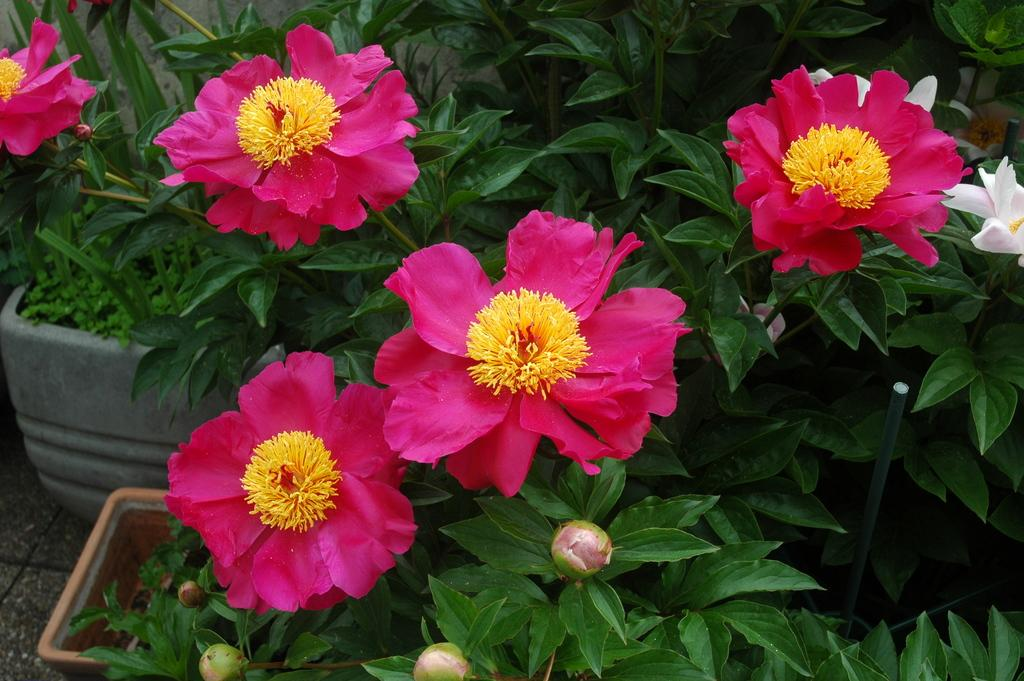What type of plants are in the image? There are potted plants in the image. What can be seen on the potted plants? The potted plants have flowers and buds. What type of soda is being poured into the potted plants in the image? There is no soda present in the image; it only features potted plants with flowers and buds. 